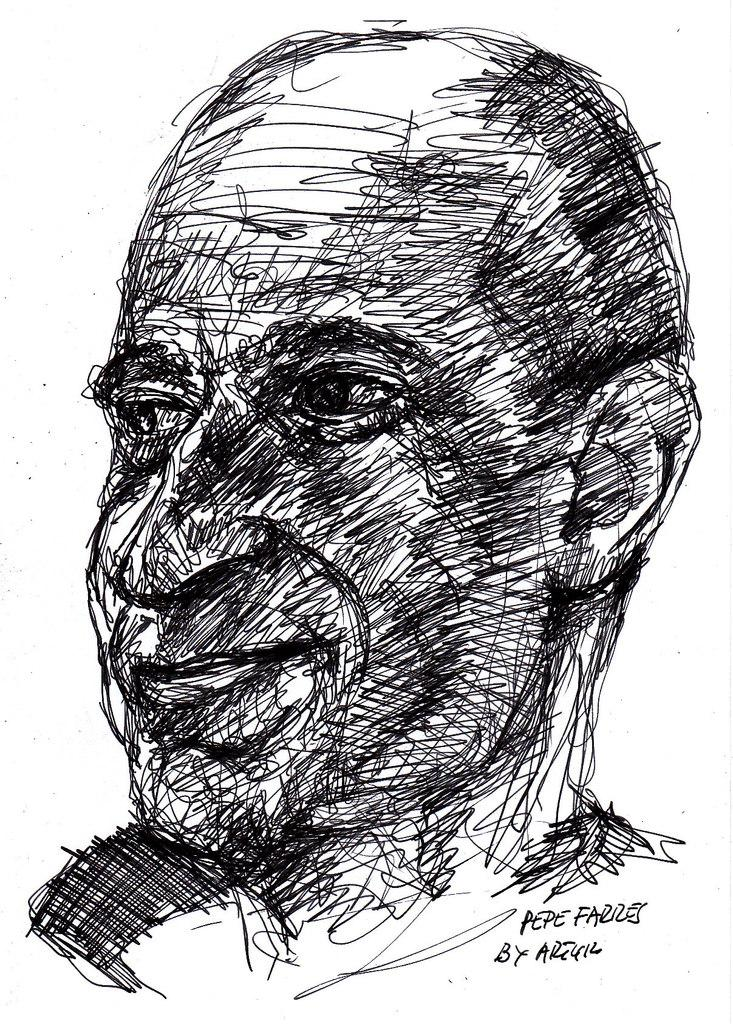What is the main subject of the image? There is a picture of a man in the image. What is the man's facial expression? The man is smiling. In which direction is the man looking? The man is looking to the left side. What can be seen behind the man in the image? There is a white surface in the backdrop of the image. What type of protest is happening in the image? There is no protest present in the image; it features a picture of a man smiling and looking to the left side. What country is the man from in the image? There is no information about the man's country of origin in the image. 